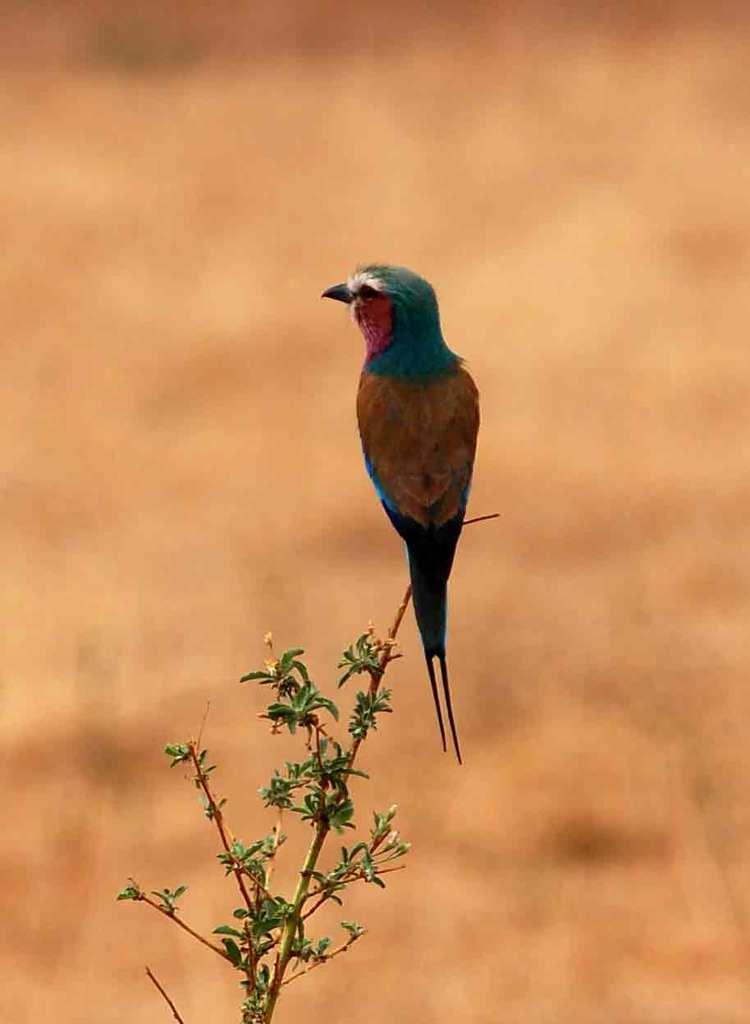What type of bird is in the image? There is a roller bird in the image. Where is the roller bird located? The roller bird is standing on the stem of a plant. What type of airplane is the roller bird flying in the image? There is no airplane present in the image; the roller bird is standing on the stem of a plant. What hobbies does the roller bird have, as depicted in the image? The image does not provide information about the roller bird's hobbies. How many rings is the roller bird wearing in the image? There are no rings visible on the roller bird in the image. 